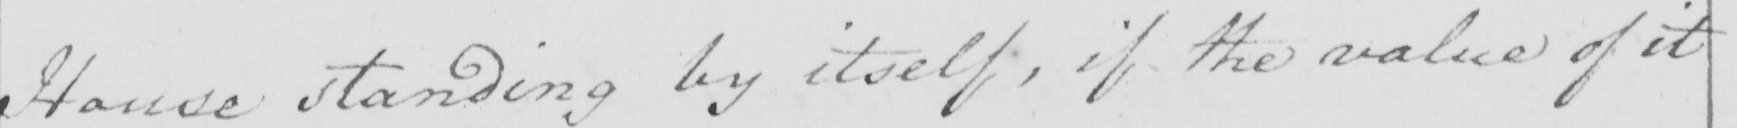What does this handwritten line say? House standing by itself , if the value of it 